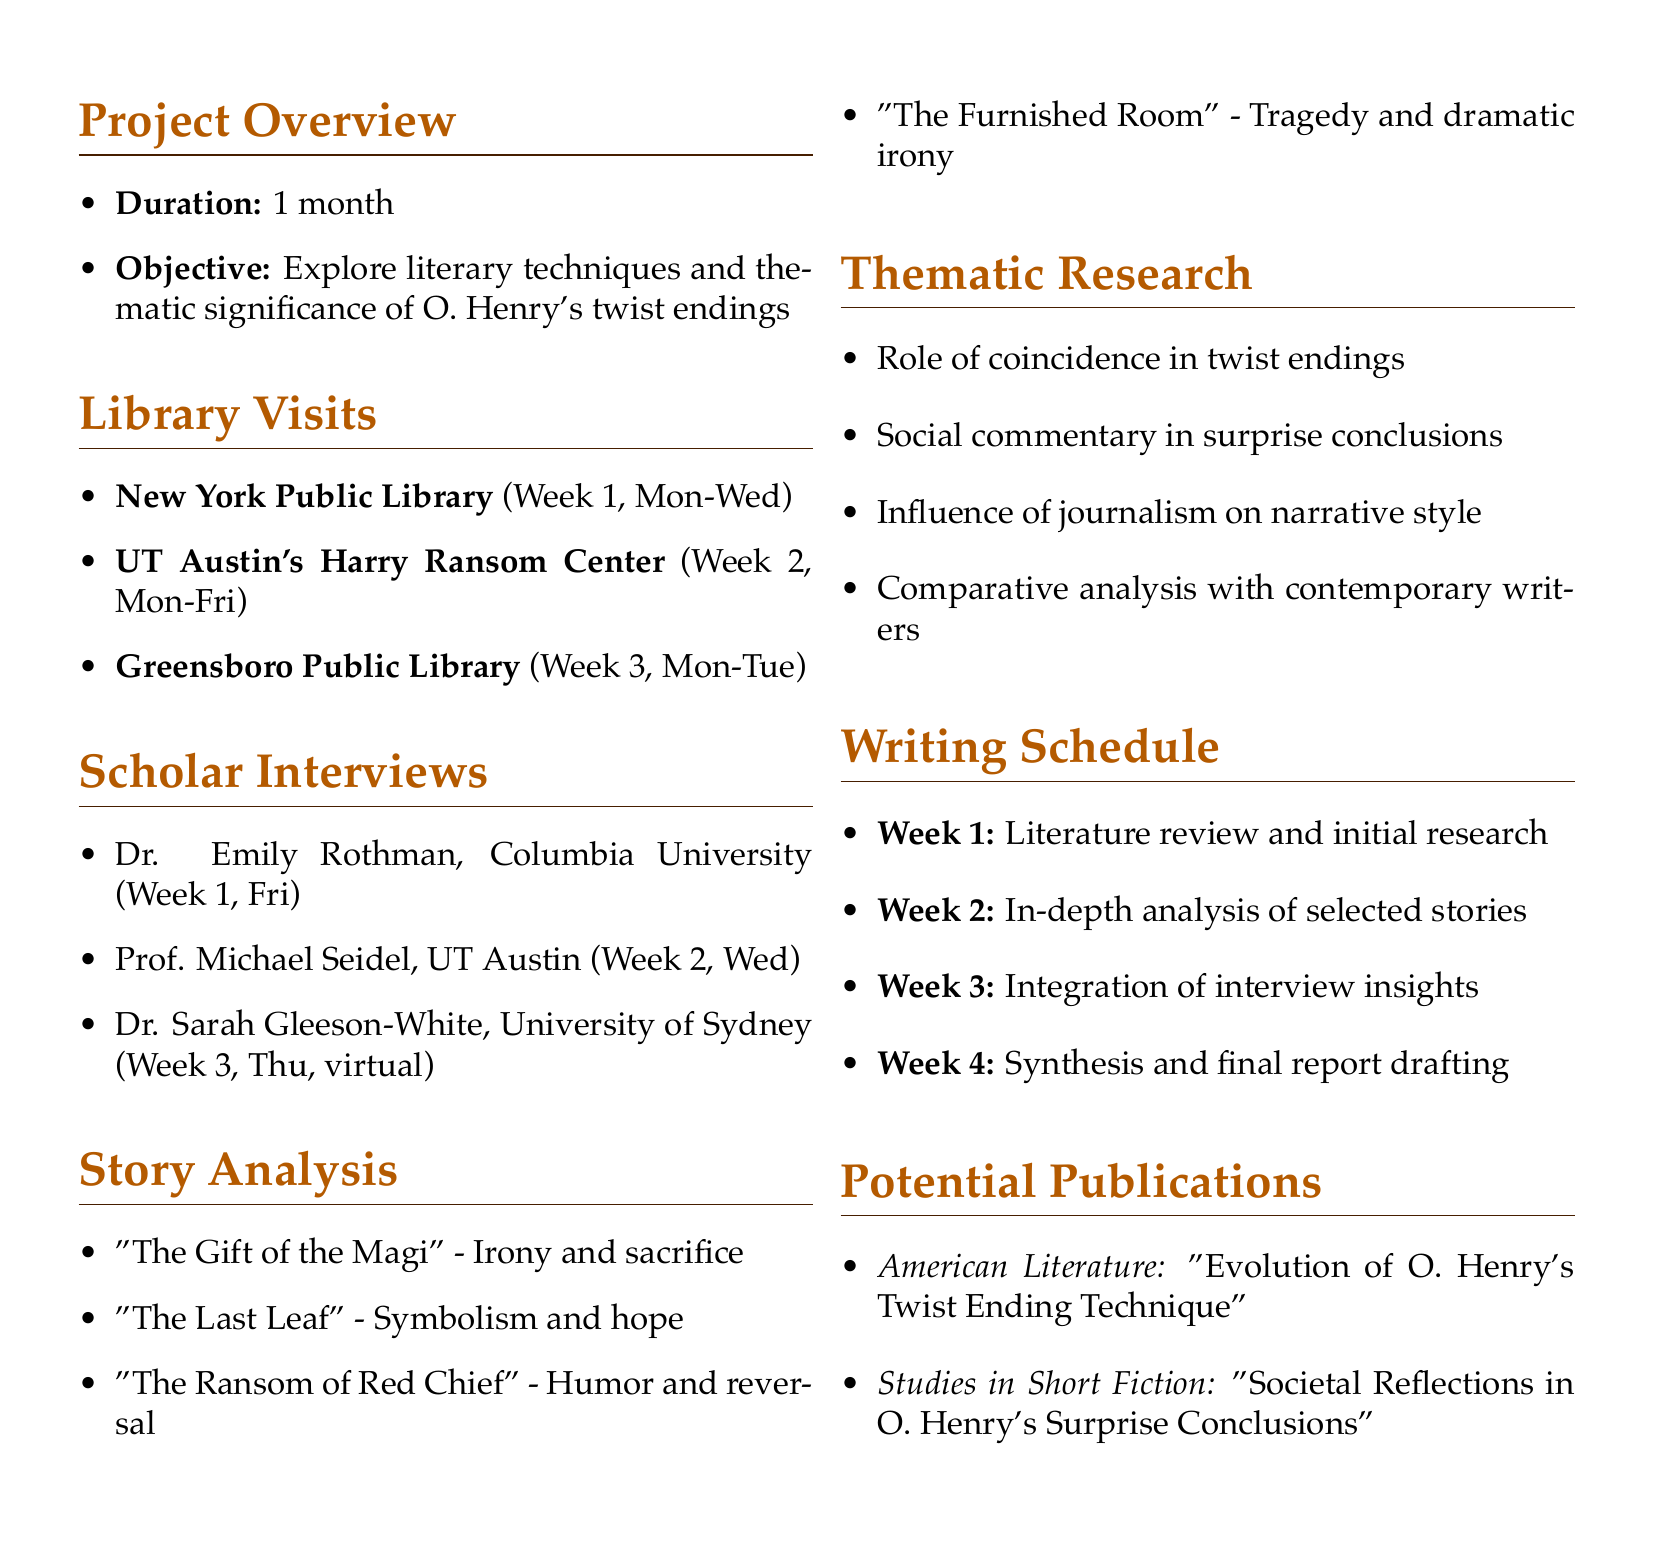what is the title of the project? The title of the project is found in the header of the document.
Answer: O. Henry's Twist Endings: A Comprehensive Analysis how many weeks will the project last? The duration of the project is specifically mentioned in the project overview section.
Answer: 1 month which library will be visited in Week 2? The library visits section lists libraries and their respective weeks for visits.
Answer: University of Texas at Austin's Harry Ransom Center who is the expert on O. Henry's writing process? The scholar interviews section identifies experts and their focus areas.
Answer: Prof. Michael Seidel what is the focus of the story "The Last Leaf"? The story analysis section provides the focus for each analyzed story.
Answer: Symbolism and hope in unexpected resolutions which research theme relates to journalism's influence? The thematic research section includes various topics of investigation.
Answer: Influence of journalism on O. Henry's narrative style when will the final report drafting take place? The writing schedule outlines tasks for each week, including report drafting.
Answer: Week 4 what is a potential publication mentioned in the document? The potential publications section lists journals and their focus areas.
Answer: American Literature 